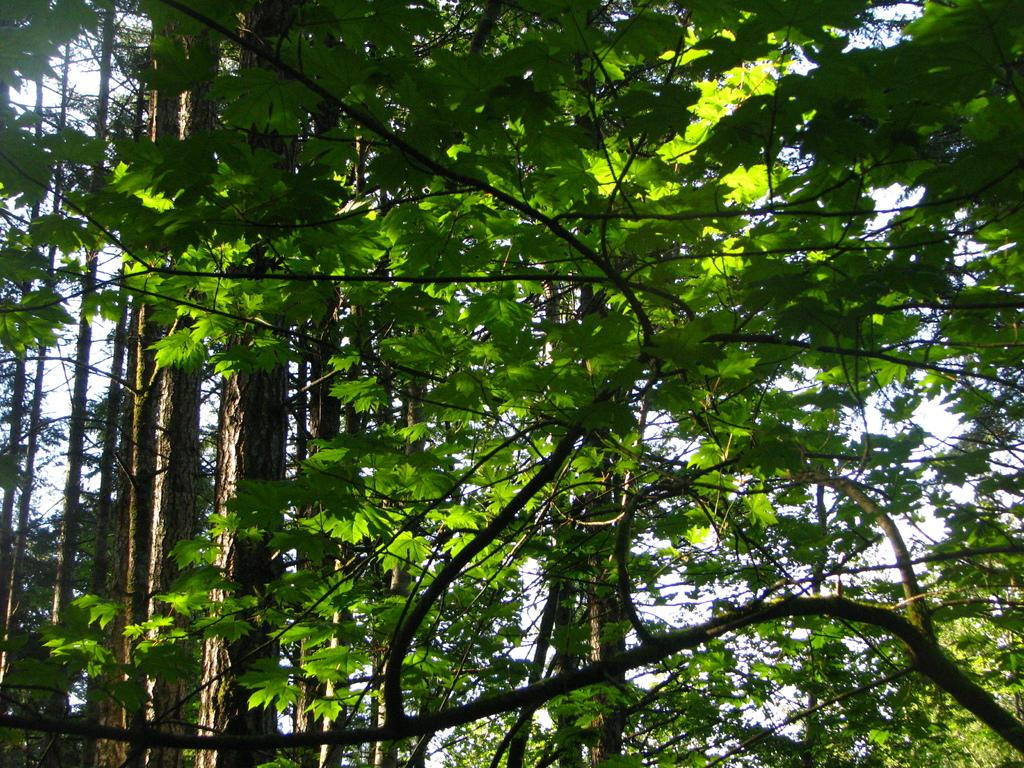Where was the image taken? The image was clicked outside. What can be seen in the center of the image? There are trees in the center of the image. What part of the natural environment is visible in the image? The sky is visible in the image. How many cats are involved in the trade depicted in the image? There are no cats or any depiction of trade present in the image. 